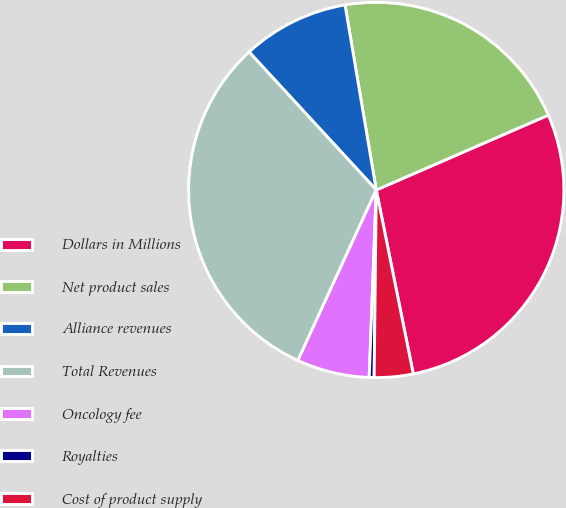<chart> <loc_0><loc_0><loc_500><loc_500><pie_chart><fcel>Dollars in Millions<fcel>Net product sales<fcel>Alliance revenues<fcel>Total Revenues<fcel>Oncology fee<fcel>Royalties<fcel>Cost of product supply<nl><fcel>28.37%<fcel>21.13%<fcel>9.19%<fcel>31.29%<fcel>6.26%<fcel>0.42%<fcel>3.34%<nl></chart> 